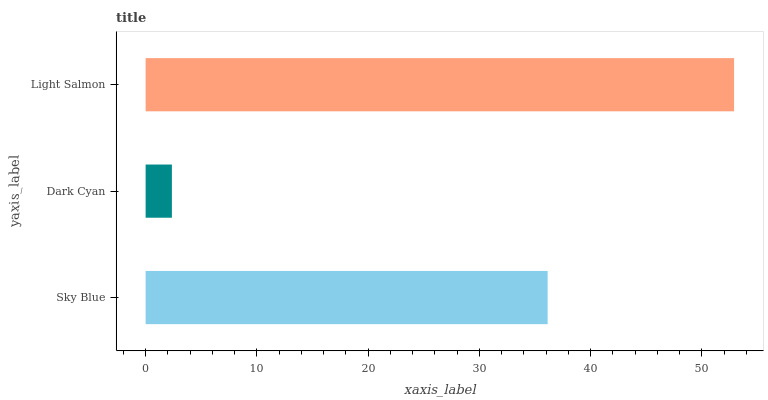Is Dark Cyan the minimum?
Answer yes or no. Yes. Is Light Salmon the maximum?
Answer yes or no. Yes. Is Light Salmon the minimum?
Answer yes or no. No. Is Dark Cyan the maximum?
Answer yes or no. No. Is Light Salmon greater than Dark Cyan?
Answer yes or no. Yes. Is Dark Cyan less than Light Salmon?
Answer yes or no. Yes. Is Dark Cyan greater than Light Salmon?
Answer yes or no. No. Is Light Salmon less than Dark Cyan?
Answer yes or no. No. Is Sky Blue the high median?
Answer yes or no. Yes. Is Sky Blue the low median?
Answer yes or no. Yes. Is Light Salmon the high median?
Answer yes or no. No. Is Light Salmon the low median?
Answer yes or no. No. 